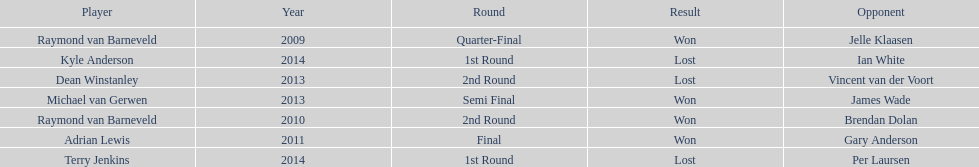Is dean winstanley listed above or below kyle anderson? Above. 